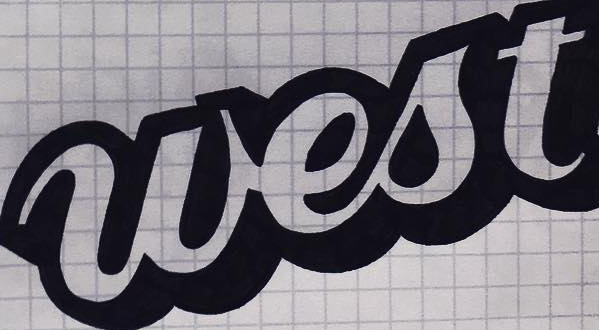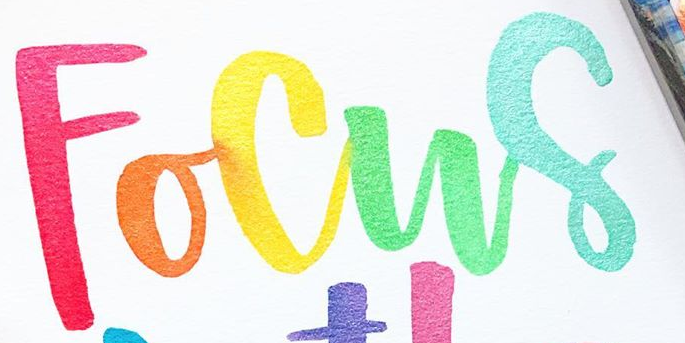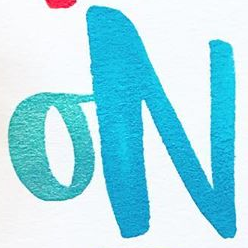What words are shown in these images in order, separated by a semicolon? west; Focus; ON 